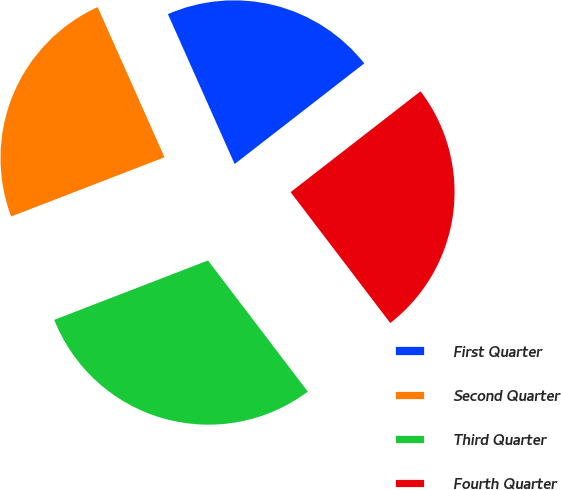Convert chart to OTSL. <chart><loc_0><loc_0><loc_500><loc_500><pie_chart><fcel>First Quarter<fcel>Second Quarter<fcel>Third Quarter<fcel>Fourth Quarter<nl><fcel>21.16%<fcel>24.2%<fcel>29.49%<fcel>25.15%<nl></chart> 